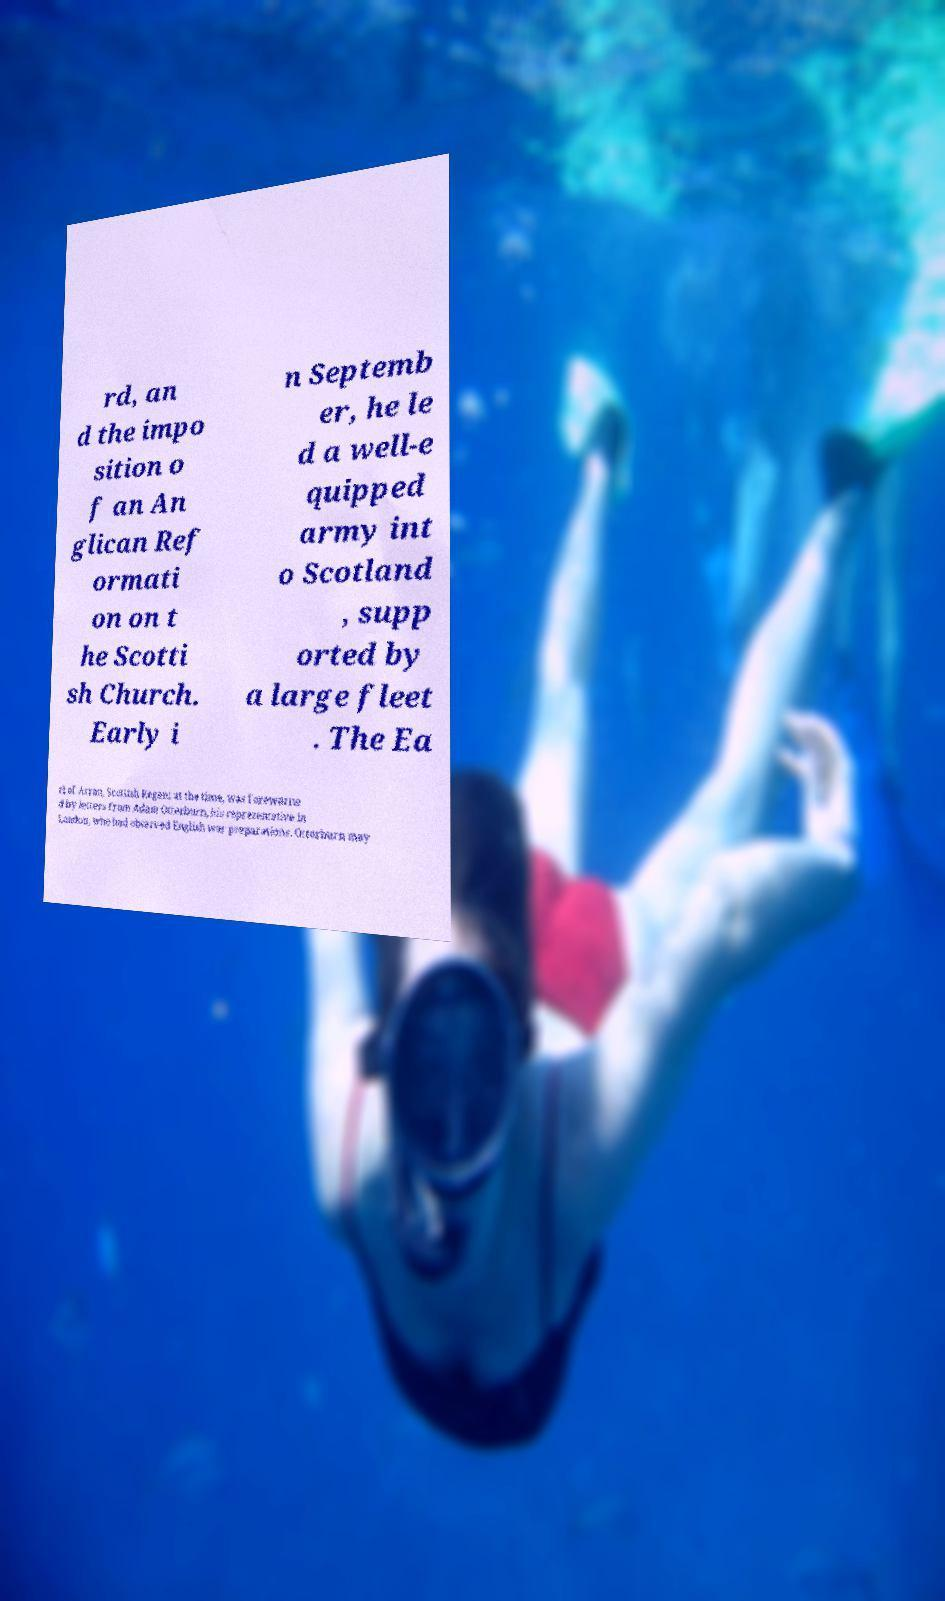Could you extract and type out the text from this image? rd, an d the impo sition o f an An glican Ref ormati on on t he Scotti sh Church. Early i n Septemb er, he le d a well-e quipped army int o Scotland , supp orted by a large fleet . The Ea rl of Arran, Scottish Regent at the time, was forewarne d by letters from Adam Otterburn, his representative in London, who had observed English war preparations. Otterburn may 